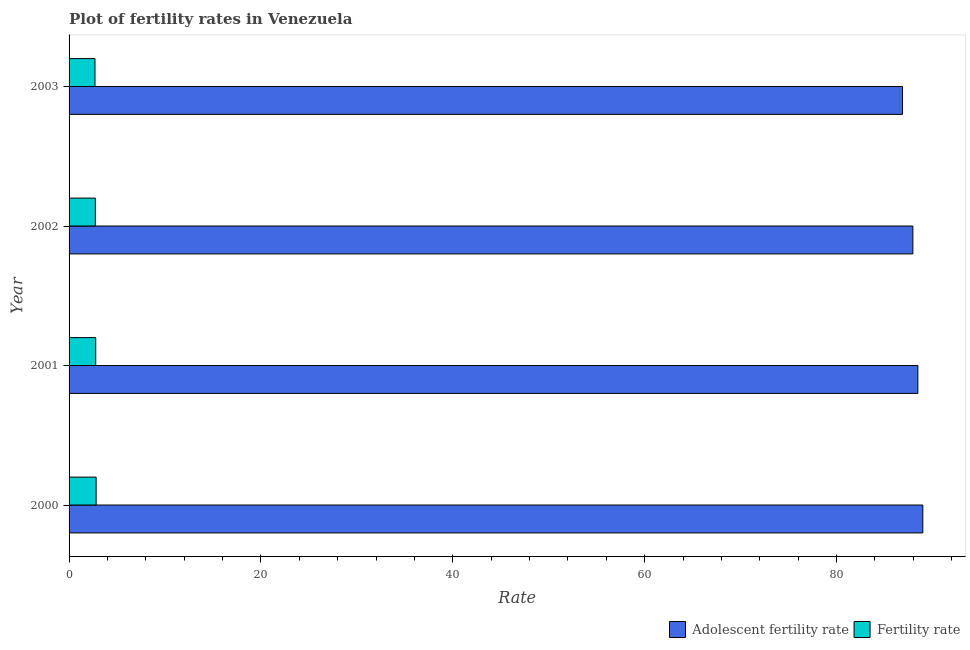How many different coloured bars are there?
Ensure brevity in your answer.  2. How many groups of bars are there?
Your response must be concise. 4. Are the number of bars per tick equal to the number of legend labels?
Provide a short and direct response. Yes. Are the number of bars on each tick of the Y-axis equal?
Offer a very short reply. Yes. How many bars are there on the 4th tick from the top?
Your answer should be compact. 2. How many bars are there on the 3rd tick from the bottom?
Keep it short and to the point. 2. What is the adolescent fertility rate in 2003?
Your response must be concise. 86.88. Across all years, what is the maximum adolescent fertility rate?
Provide a succinct answer. 89. Across all years, what is the minimum fertility rate?
Offer a very short reply. 2.7. In which year was the fertility rate minimum?
Give a very brief answer. 2003. What is the total adolescent fertility rate in the graph?
Offer a very short reply. 352.32. What is the difference between the adolescent fertility rate in 2001 and the fertility rate in 2003?
Provide a short and direct response. 85.78. What is the average fertility rate per year?
Give a very brief answer. 2.76. In the year 2000, what is the difference between the adolescent fertility rate and fertility rate?
Ensure brevity in your answer.  86.18. What is the ratio of the fertility rate in 2001 to that in 2002?
Offer a very short reply. 1.01. Is the difference between the adolescent fertility rate in 2001 and 2002 greater than the difference between the fertility rate in 2001 and 2002?
Keep it short and to the point. Yes. What is the difference between the highest and the second highest fertility rate?
Provide a short and direct response. 0.04. What is the difference between the highest and the lowest adolescent fertility rate?
Your answer should be very brief. 2.12. In how many years, is the fertility rate greater than the average fertility rate taken over all years?
Provide a short and direct response. 2. What does the 2nd bar from the top in 2000 represents?
Your response must be concise. Adolescent fertility rate. What does the 2nd bar from the bottom in 2001 represents?
Offer a very short reply. Fertility rate. Are all the bars in the graph horizontal?
Offer a very short reply. Yes. What is the difference between two consecutive major ticks on the X-axis?
Make the answer very short. 20. Are the values on the major ticks of X-axis written in scientific E-notation?
Provide a short and direct response. No. Does the graph contain any zero values?
Ensure brevity in your answer.  No. Does the graph contain grids?
Give a very brief answer. No. Where does the legend appear in the graph?
Your answer should be very brief. Bottom right. How are the legend labels stacked?
Give a very brief answer. Horizontal. What is the title of the graph?
Your answer should be compact. Plot of fertility rates in Venezuela. Does "Tetanus" appear as one of the legend labels in the graph?
Keep it short and to the point. No. What is the label or title of the X-axis?
Make the answer very short. Rate. What is the Rate in Adolescent fertility rate in 2000?
Give a very brief answer. 89. What is the Rate of Fertility rate in 2000?
Your answer should be very brief. 2.82. What is the Rate of Adolescent fertility rate in 2001?
Your response must be concise. 88.48. What is the Rate of Fertility rate in 2001?
Your answer should be very brief. 2.78. What is the Rate of Adolescent fertility rate in 2002?
Offer a terse response. 87.96. What is the Rate of Fertility rate in 2002?
Provide a succinct answer. 2.74. What is the Rate of Adolescent fertility rate in 2003?
Offer a very short reply. 86.88. What is the Rate in Fertility rate in 2003?
Ensure brevity in your answer.  2.7. Across all years, what is the maximum Rate in Adolescent fertility rate?
Provide a short and direct response. 89. Across all years, what is the maximum Rate in Fertility rate?
Offer a terse response. 2.82. Across all years, what is the minimum Rate of Adolescent fertility rate?
Give a very brief answer. 86.88. Across all years, what is the minimum Rate of Fertility rate?
Your answer should be compact. 2.7. What is the total Rate in Adolescent fertility rate in the graph?
Give a very brief answer. 352.32. What is the total Rate in Fertility rate in the graph?
Offer a very short reply. 11.04. What is the difference between the Rate of Adolescent fertility rate in 2000 and that in 2001?
Your response must be concise. 0.52. What is the difference between the Rate of Fertility rate in 2000 and that in 2001?
Your response must be concise. 0.04. What is the difference between the Rate of Adolescent fertility rate in 2000 and that in 2002?
Provide a succinct answer. 1.04. What is the difference between the Rate in Fertility rate in 2000 and that in 2002?
Give a very brief answer. 0.08. What is the difference between the Rate in Adolescent fertility rate in 2000 and that in 2003?
Offer a terse response. 2.12. What is the difference between the Rate in Fertility rate in 2000 and that in 2003?
Your answer should be very brief. 0.12. What is the difference between the Rate of Adolescent fertility rate in 2001 and that in 2002?
Give a very brief answer. 0.52. What is the difference between the Rate of Fertility rate in 2001 and that in 2002?
Make the answer very short. 0.04. What is the difference between the Rate of Adolescent fertility rate in 2001 and that in 2003?
Offer a very short reply. 1.6. What is the difference between the Rate in Fertility rate in 2001 and that in 2003?
Provide a succinct answer. 0.08. What is the difference between the Rate of Adolescent fertility rate in 2002 and that in 2003?
Ensure brevity in your answer.  1.08. What is the difference between the Rate of Fertility rate in 2002 and that in 2003?
Your answer should be very brief. 0.04. What is the difference between the Rate in Adolescent fertility rate in 2000 and the Rate in Fertility rate in 2001?
Ensure brevity in your answer.  86.22. What is the difference between the Rate of Adolescent fertility rate in 2000 and the Rate of Fertility rate in 2002?
Provide a succinct answer. 86.26. What is the difference between the Rate of Adolescent fertility rate in 2000 and the Rate of Fertility rate in 2003?
Provide a succinct answer. 86.3. What is the difference between the Rate in Adolescent fertility rate in 2001 and the Rate in Fertility rate in 2002?
Offer a very short reply. 85.74. What is the difference between the Rate of Adolescent fertility rate in 2001 and the Rate of Fertility rate in 2003?
Make the answer very short. 85.78. What is the difference between the Rate of Adolescent fertility rate in 2002 and the Rate of Fertility rate in 2003?
Provide a succinct answer. 85.26. What is the average Rate of Adolescent fertility rate per year?
Offer a very short reply. 88.08. What is the average Rate in Fertility rate per year?
Your answer should be compact. 2.76. In the year 2000, what is the difference between the Rate of Adolescent fertility rate and Rate of Fertility rate?
Give a very brief answer. 86.18. In the year 2001, what is the difference between the Rate of Adolescent fertility rate and Rate of Fertility rate?
Keep it short and to the point. 85.7. In the year 2002, what is the difference between the Rate of Adolescent fertility rate and Rate of Fertility rate?
Provide a short and direct response. 85.22. In the year 2003, what is the difference between the Rate in Adolescent fertility rate and Rate in Fertility rate?
Your answer should be compact. 84.18. What is the ratio of the Rate of Fertility rate in 2000 to that in 2001?
Offer a very short reply. 1.02. What is the ratio of the Rate of Adolescent fertility rate in 2000 to that in 2002?
Give a very brief answer. 1.01. What is the ratio of the Rate of Fertility rate in 2000 to that in 2002?
Your answer should be compact. 1.03. What is the ratio of the Rate in Adolescent fertility rate in 2000 to that in 2003?
Ensure brevity in your answer.  1.02. What is the ratio of the Rate of Fertility rate in 2000 to that in 2003?
Make the answer very short. 1.04. What is the ratio of the Rate of Adolescent fertility rate in 2001 to that in 2002?
Keep it short and to the point. 1.01. What is the ratio of the Rate of Fertility rate in 2001 to that in 2002?
Ensure brevity in your answer.  1.01. What is the ratio of the Rate of Adolescent fertility rate in 2001 to that in 2003?
Give a very brief answer. 1.02. What is the ratio of the Rate of Fertility rate in 2001 to that in 2003?
Your answer should be very brief. 1.03. What is the ratio of the Rate of Adolescent fertility rate in 2002 to that in 2003?
Your answer should be very brief. 1.01. What is the ratio of the Rate of Fertility rate in 2002 to that in 2003?
Your response must be concise. 1.01. What is the difference between the highest and the second highest Rate in Adolescent fertility rate?
Ensure brevity in your answer.  0.52. What is the difference between the highest and the second highest Rate of Fertility rate?
Make the answer very short. 0.04. What is the difference between the highest and the lowest Rate in Adolescent fertility rate?
Provide a succinct answer. 2.12. What is the difference between the highest and the lowest Rate in Fertility rate?
Offer a terse response. 0.12. 